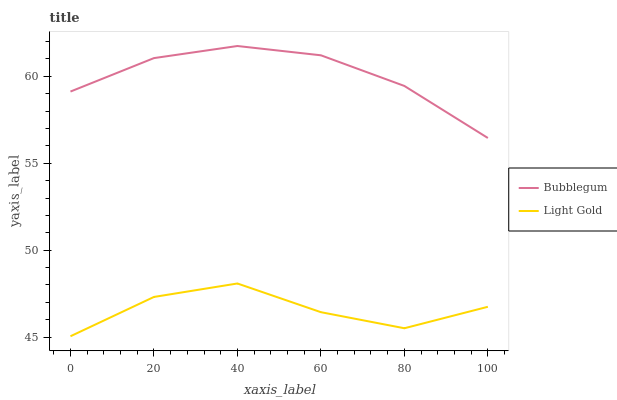Does Light Gold have the minimum area under the curve?
Answer yes or no. Yes. Does Bubblegum have the maximum area under the curve?
Answer yes or no. Yes. Does Bubblegum have the minimum area under the curve?
Answer yes or no. No. Is Bubblegum the smoothest?
Answer yes or no. Yes. Is Light Gold the roughest?
Answer yes or no. Yes. Is Bubblegum the roughest?
Answer yes or no. No. Does Light Gold have the lowest value?
Answer yes or no. Yes. Does Bubblegum have the lowest value?
Answer yes or no. No. Does Bubblegum have the highest value?
Answer yes or no. Yes. Is Light Gold less than Bubblegum?
Answer yes or no. Yes. Is Bubblegum greater than Light Gold?
Answer yes or no. Yes. Does Light Gold intersect Bubblegum?
Answer yes or no. No. 